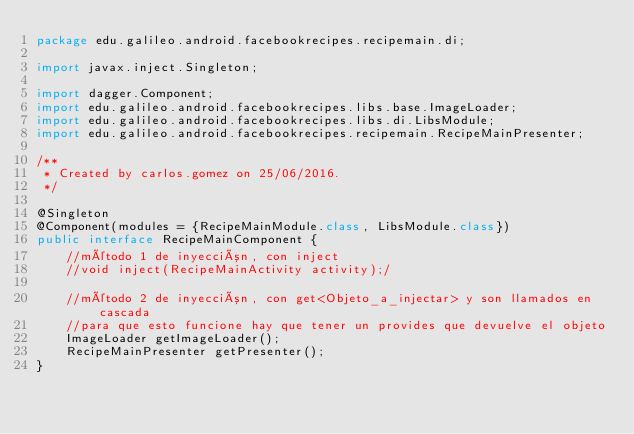Convert code to text. <code><loc_0><loc_0><loc_500><loc_500><_Java_>package edu.galileo.android.facebookrecipes.recipemain.di;

import javax.inject.Singleton;

import dagger.Component;
import edu.galileo.android.facebookrecipes.libs.base.ImageLoader;
import edu.galileo.android.facebookrecipes.libs.di.LibsModule;
import edu.galileo.android.facebookrecipes.recipemain.RecipeMainPresenter;

/**
 * Created by carlos.gomez on 25/06/2016.
 */

@Singleton
@Component(modules = {RecipeMainModule.class, LibsModule.class})
public interface RecipeMainComponent {
    //método 1 de inyección, con inject
    //void inject(RecipeMainActivity activity);/

    //método 2 de inyección, con get<Objeto_a_injectar> y son llamados en cascada
    //para que esto funcione hay que tener un provides que devuelve el objeto
    ImageLoader getImageLoader();
    RecipeMainPresenter getPresenter();
}
</code> 